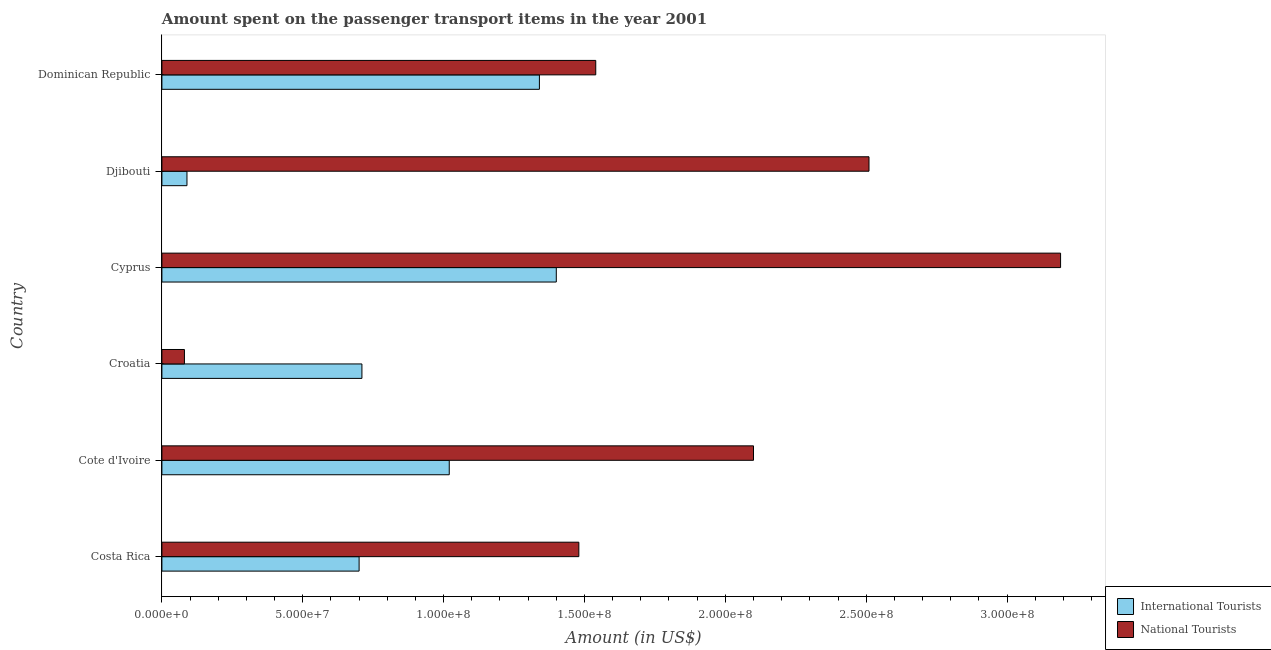How many groups of bars are there?
Your answer should be very brief. 6. Are the number of bars per tick equal to the number of legend labels?
Provide a succinct answer. Yes. Are the number of bars on each tick of the Y-axis equal?
Give a very brief answer. Yes. How many bars are there on the 4th tick from the top?
Your answer should be very brief. 2. How many bars are there on the 6th tick from the bottom?
Offer a terse response. 2. What is the label of the 1st group of bars from the top?
Your response must be concise. Dominican Republic. In how many cases, is the number of bars for a given country not equal to the number of legend labels?
Give a very brief answer. 0. What is the amount spent on transport items of international tourists in Djibouti?
Give a very brief answer. 8.90e+06. Across all countries, what is the maximum amount spent on transport items of international tourists?
Offer a terse response. 1.40e+08. Across all countries, what is the minimum amount spent on transport items of international tourists?
Offer a very short reply. 8.90e+06. In which country was the amount spent on transport items of national tourists maximum?
Keep it short and to the point. Cyprus. In which country was the amount spent on transport items of national tourists minimum?
Provide a succinct answer. Croatia. What is the total amount spent on transport items of international tourists in the graph?
Your answer should be compact. 5.26e+08. What is the difference between the amount spent on transport items of national tourists in Croatia and that in Djibouti?
Provide a short and direct response. -2.43e+08. What is the difference between the amount spent on transport items of international tourists in Cyprus and the amount spent on transport items of national tourists in Djibouti?
Give a very brief answer. -1.11e+08. What is the average amount spent on transport items of national tourists per country?
Make the answer very short. 1.82e+08. What is the difference between the amount spent on transport items of international tourists and amount spent on transport items of national tourists in Cote d'Ivoire?
Offer a terse response. -1.08e+08. In how many countries, is the amount spent on transport items of national tourists greater than 300000000 US$?
Give a very brief answer. 1. What is the ratio of the amount spent on transport items of international tourists in Djibouti to that in Dominican Republic?
Give a very brief answer. 0.07. Is the difference between the amount spent on transport items of national tourists in Costa Rica and Cyprus greater than the difference between the amount spent on transport items of international tourists in Costa Rica and Cyprus?
Offer a very short reply. No. What is the difference between the highest and the second highest amount spent on transport items of international tourists?
Ensure brevity in your answer.  6.00e+06. What is the difference between the highest and the lowest amount spent on transport items of national tourists?
Make the answer very short. 3.11e+08. In how many countries, is the amount spent on transport items of international tourists greater than the average amount spent on transport items of international tourists taken over all countries?
Give a very brief answer. 3. What does the 2nd bar from the top in Cote d'Ivoire represents?
Your answer should be compact. International Tourists. What does the 1st bar from the bottom in Cyprus represents?
Give a very brief answer. International Tourists. How many countries are there in the graph?
Offer a terse response. 6. What is the difference between two consecutive major ticks on the X-axis?
Your answer should be very brief. 5.00e+07. Where does the legend appear in the graph?
Ensure brevity in your answer.  Bottom right. What is the title of the graph?
Keep it short and to the point. Amount spent on the passenger transport items in the year 2001. Does "Formally registered" appear as one of the legend labels in the graph?
Provide a succinct answer. No. What is the label or title of the Y-axis?
Provide a succinct answer. Country. What is the Amount (in US$) in International Tourists in Costa Rica?
Ensure brevity in your answer.  7.00e+07. What is the Amount (in US$) in National Tourists in Costa Rica?
Your answer should be compact. 1.48e+08. What is the Amount (in US$) in International Tourists in Cote d'Ivoire?
Provide a succinct answer. 1.02e+08. What is the Amount (in US$) in National Tourists in Cote d'Ivoire?
Give a very brief answer. 2.10e+08. What is the Amount (in US$) of International Tourists in Croatia?
Offer a terse response. 7.10e+07. What is the Amount (in US$) of International Tourists in Cyprus?
Offer a very short reply. 1.40e+08. What is the Amount (in US$) of National Tourists in Cyprus?
Your answer should be compact. 3.19e+08. What is the Amount (in US$) in International Tourists in Djibouti?
Ensure brevity in your answer.  8.90e+06. What is the Amount (in US$) of National Tourists in Djibouti?
Offer a terse response. 2.51e+08. What is the Amount (in US$) of International Tourists in Dominican Republic?
Provide a succinct answer. 1.34e+08. What is the Amount (in US$) of National Tourists in Dominican Republic?
Your response must be concise. 1.54e+08. Across all countries, what is the maximum Amount (in US$) in International Tourists?
Offer a very short reply. 1.40e+08. Across all countries, what is the maximum Amount (in US$) in National Tourists?
Your response must be concise. 3.19e+08. Across all countries, what is the minimum Amount (in US$) in International Tourists?
Your answer should be compact. 8.90e+06. Across all countries, what is the minimum Amount (in US$) in National Tourists?
Your answer should be compact. 8.00e+06. What is the total Amount (in US$) in International Tourists in the graph?
Make the answer very short. 5.26e+08. What is the total Amount (in US$) of National Tourists in the graph?
Give a very brief answer. 1.09e+09. What is the difference between the Amount (in US$) in International Tourists in Costa Rica and that in Cote d'Ivoire?
Give a very brief answer. -3.20e+07. What is the difference between the Amount (in US$) in National Tourists in Costa Rica and that in Cote d'Ivoire?
Your response must be concise. -6.20e+07. What is the difference between the Amount (in US$) in International Tourists in Costa Rica and that in Croatia?
Offer a very short reply. -1.00e+06. What is the difference between the Amount (in US$) of National Tourists in Costa Rica and that in Croatia?
Provide a short and direct response. 1.40e+08. What is the difference between the Amount (in US$) in International Tourists in Costa Rica and that in Cyprus?
Give a very brief answer. -7.00e+07. What is the difference between the Amount (in US$) in National Tourists in Costa Rica and that in Cyprus?
Provide a succinct answer. -1.71e+08. What is the difference between the Amount (in US$) of International Tourists in Costa Rica and that in Djibouti?
Your response must be concise. 6.11e+07. What is the difference between the Amount (in US$) in National Tourists in Costa Rica and that in Djibouti?
Give a very brief answer. -1.03e+08. What is the difference between the Amount (in US$) in International Tourists in Costa Rica and that in Dominican Republic?
Give a very brief answer. -6.40e+07. What is the difference between the Amount (in US$) in National Tourists in Costa Rica and that in Dominican Republic?
Make the answer very short. -6.00e+06. What is the difference between the Amount (in US$) in International Tourists in Cote d'Ivoire and that in Croatia?
Your response must be concise. 3.10e+07. What is the difference between the Amount (in US$) in National Tourists in Cote d'Ivoire and that in Croatia?
Offer a terse response. 2.02e+08. What is the difference between the Amount (in US$) in International Tourists in Cote d'Ivoire and that in Cyprus?
Your answer should be compact. -3.80e+07. What is the difference between the Amount (in US$) in National Tourists in Cote d'Ivoire and that in Cyprus?
Keep it short and to the point. -1.09e+08. What is the difference between the Amount (in US$) of International Tourists in Cote d'Ivoire and that in Djibouti?
Give a very brief answer. 9.31e+07. What is the difference between the Amount (in US$) in National Tourists in Cote d'Ivoire and that in Djibouti?
Give a very brief answer. -4.10e+07. What is the difference between the Amount (in US$) in International Tourists in Cote d'Ivoire and that in Dominican Republic?
Your answer should be very brief. -3.20e+07. What is the difference between the Amount (in US$) in National Tourists in Cote d'Ivoire and that in Dominican Republic?
Your response must be concise. 5.60e+07. What is the difference between the Amount (in US$) of International Tourists in Croatia and that in Cyprus?
Provide a short and direct response. -6.90e+07. What is the difference between the Amount (in US$) in National Tourists in Croatia and that in Cyprus?
Your answer should be compact. -3.11e+08. What is the difference between the Amount (in US$) of International Tourists in Croatia and that in Djibouti?
Offer a very short reply. 6.21e+07. What is the difference between the Amount (in US$) in National Tourists in Croatia and that in Djibouti?
Your response must be concise. -2.43e+08. What is the difference between the Amount (in US$) in International Tourists in Croatia and that in Dominican Republic?
Offer a terse response. -6.30e+07. What is the difference between the Amount (in US$) in National Tourists in Croatia and that in Dominican Republic?
Keep it short and to the point. -1.46e+08. What is the difference between the Amount (in US$) in International Tourists in Cyprus and that in Djibouti?
Your answer should be compact. 1.31e+08. What is the difference between the Amount (in US$) of National Tourists in Cyprus and that in Djibouti?
Keep it short and to the point. 6.80e+07. What is the difference between the Amount (in US$) of National Tourists in Cyprus and that in Dominican Republic?
Your answer should be very brief. 1.65e+08. What is the difference between the Amount (in US$) in International Tourists in Djibouti and that in Dominican Republic?
Offer a terse response. -1.25e+08. What is the difference between the Amount (in US$) in National Tourists in Djibouti and that in Dominican Republic?
Your response must be concise. 9.70e+07. What is the difference between the Amount (in US$) in International Tourists in Costa Rica and the Amount (in US$) in National Tourists in Cote d'Ivoire?
Make the answer very short. -1.40e+08. What is the difference between the Amount (in US$) of International Tourists in Costa Rica and the Amount (in US$) of National Tourists in Croatia?
Your answer should be very brief. 6.20e+07. What is the difference between the Amount (in US$) in International Tourists in Costa Rica and the Amount (in US$) in National Tourists in Cyprus?
Keep it short and to the point. -2.49e+08. What is the difference between the Amount (in US$) in International Tourists in Costa Rica and the Amount (in US$) in National Tourists in Djibouti?
Provide a short and direct response. -1.81e+08. What is the difference between the Amount (in US$) of International Tourists in Costa Rica and the Amount (in US$) of National Tourists in Dominican Republic?
Offer a very short reply. -8.40e+07. What is the difference between the Amount (in US$) in International Tourists in Cote d'Ivoire and the Amount (in US$) in National Tourists in Croatia?
Your answer should be compact. 9.40e+07. What is the difference between the Amount (in US$) in International Tourists in Cote d'Ivoire and the Amount (in US$) in National Tourists in Cyprus?
Ensure brevity in your answer.  -2.17e+08. What is the difference between the Amount (in US$) of International Tourists in Cote d'Ivoire and the Amount (in US$) of National Tourists in Djibouti?
Provide a succinct answer. -1.49e+08. What is the difference between the Amount (in US$) in International Tourists in Cote d'Ivoire and the Amount (in US$) in National Tourists in Dominican Republic?
Ensure brevity in your answer.  -5.20e+07. What is the difference between the Amount (in US$) of International Tourists in Croatia and the Amount (in US$) of National Tourists in Cyprus?
Keep it short and to the point. -2.48e+08. What is the difference between the Amount (in US$) in International Tourists in Croatia and the Amount (in US$) in National Tourists in Djibouti?
Offer a very short reply. -1.80e+08. What is the difference between the Amount (in US$) in International Tourists in Croatia and the Amount (in US$) in National Tourists in Dominican Republic?
Provide a succinct answer. -8.30e+07. What is the difference between the Amount (in US$) of International Tourists in Cyprus and the Amount (in US$) of National Tourists in Djibouti?
Your answer should be compact. -1.11e+08. What is the difference between the Amount (in US$) in International Tourists in Cyprus and the Amount (in US$) in National Tourists in Dominican Republic?
Provide a succinct answer. -1.40e+07. What is the difference between the Amount (in US$) in International Tourists in Djibouti and the Amount (in US$) in National Tourists in Dominican Republic?
Keep it short and to the point. -1.45e+08. What is the average Amount (in US$) in International Tourists per country?
Ensure brevity in your answer.  8.76e+07. What is the average Amount (in US$) in National Tourists per country?
Provide a short and direct response. 1.82e+08. What is the difference between the Amount (in US$) of International Tourists and Amount (in US$) of National Tourists in Costa Rica?
Your answer should be very brief. -7.80e+07. What is the difference between the Amount (in US$) of International Tourists and Amount (in US$) of National Tourists in Cote d'Ivoire?
Give a very brief answer. -1.08e+08. What is the difference between the Amount (in US$) of International Tourists and Amount (in US$) of National Tourists in Croatia?
Give a very brief answer. 6.30e+07. What is the difference between the Amount (in US$) of International Tourists and Amount (in US$) of National Tourists in Cyprus?
Give a very brief answer. -1.79e+08. What is the difference between the Amount (in US$) in International Tourists and Amount (in US$) in National Tourists in Djibouti?
Offer a terse response. -2.42e+08. What is the difference between the Amount (in US$) of International Tourists and Amount (in US$) of National Tourists in Dominican Republic?
Make the answer very short. -2.00e+07. What is the ratio of the Amount (in US$) in International Tourists in Costa Rica to that in Cote d'Ivoire?
Give a very brief answer. 0.69. What is the ratio of the Amount (in US$) in National Tourists in Costa Rica to that in Cote d'Ivoire?
Your answer should be very brief. 0.7. What is the ratio of the Amount (in US$) in International Tourists in Costa Rica to that in Croatia?
Make the answer very short. 0.99. What is the ratio of the Amount (in US$) in National Tourists in Costa Rica to that in Croatia?
Keep it short and to the point. 18.5. What is the ratio of the Amount (in US$) in International Tourists in Costa Rica to that in Cyprus?
Keep it short and to the point. 0.5. What is the ratio of the Amount (in US$) in National Tourists in Costa Rica to that in Cyprus?
Provide a succinct answer. 0.46. What is the ratio of the Amount (in US$) in International Tourists in Costa Rica to that in Djibouti?
Your response must be concise. 7.87. What is the ratio of the Amount (in US$) of National Tourists in Costa Rica to that in Djibouti?
Your response must be concise. 0.59. What is the ratio of the Amount (in US$) in International Tourists in Costa Rica to that in Dominican Republic?
Offer a very short reply. 0.52. What is the ratio of the Amount (in US$) in National Tourists in Costa Rica to that in Dominican Republic?
Make the answer very short. 0.96. What is the ratio of the Amount (in US$) in International Tourists in Cote d'Ivoire to that in Croatia?
Give a very brief answer. 1.44. What is the ratio of the Amount (in US$) of National Tourists in Cote d'Ivoire to that in Croatia?
Offer a very short reply. 26.25. What is the ratio of the Amount (in US$) in International Tourists in Cote d'Ivoire to that in Cyprus?
Your answer should be very brief. 0.73. What is the ratio of the Amount (in US$) of National Tourists in Cote d'Ivoire to that in Cyprus?
Your answer should be compact. 0.66. What is the ratio of the Amount (in US$) of International Tourists in Cote d'Ivoire to that in Djibouti?
Make the answer very short. 11.46. What is the ratio of the Amount (in US$) of National Tourists in Cote d'Ivoire to that in Djibouti?
Make the answer very short. 0.84. What is the ratio of the Amount (in US$) of International Tourists in Cote d'Ivoire to that in Dominican Republic?
Your answer should be compact. 0.76. What is the ratio of the Amount (in US$) of National Tourists in Cote d'Ivoire to that in Dominican Republic?
Provide a succinct answer. 1.36. What is the ratio of the Amount (in US$) in International Tourists in Croatia to that in Cyprus?
Your answer should be compact. 0.51. What is the ratio of the Amount (in US$) of National Tourists in Croatia to that in Cyprus?
Provide a short and direct response. 0.03. What is the ratio of the Amount (in US$) in International Tourists in Croatia to that in Djibouti?
Your response must be concise. 7.98. What is the ratio of the Amount (in US$) of National Tourists in Croatia to that in Djibouti?
Your answer should be very brief. 0.03. What is the ratio of the Amount (in US$) in International Tourists in Croatia to that in Dominican Republic?
Provide a short and direct response. 0.53. What is the ratio of the Amount (in US$) in National Tourists in Croatia to that in Dominican Republic?
Make the answer very short. 0.05. What is the ratio of the Amount (in US$) of International Tourists in Cyprus to that in Djibouti?
Your response must be concise. 15.73. What is the ratio of the Amount (in US$) of National Tourists in Cyprus to that in Djibouti?
Your answer should be compact. 1.27. What is the ratio of the Amount (in US$) in International Tourists in Cyprus to that in Dominican Republic?
Make the answer very short. 1.04. What is the ratio of the Amount (in US$) in National Tourists in Cyprus to that in Dominican Republic?
Keep it short and to the point. 2.07. What is the ratio of the Amount (in US$) in International Tourists in Djibouti to that in Dominican Republic?
Your answer should be compact. 0.07. What is the ratio of the Amount (in US$) of National Tourists in Djibouti to that in Dominican Republic?
Provide a short and direct response. 1.63. What is the difference between the highest and the second highest Amount (in US$) of National Tourists?
Ensure brevity in your answer.  6.80e+07. What is the difference between the highest and the lowest Amount (in US$) in International Tourists?
Provide a short and direct response. 1.31e+08. What is the difference between the highest and the lowest Amount (in US$) in National Tourists?
Your response must be concise. 3.11e+08. 